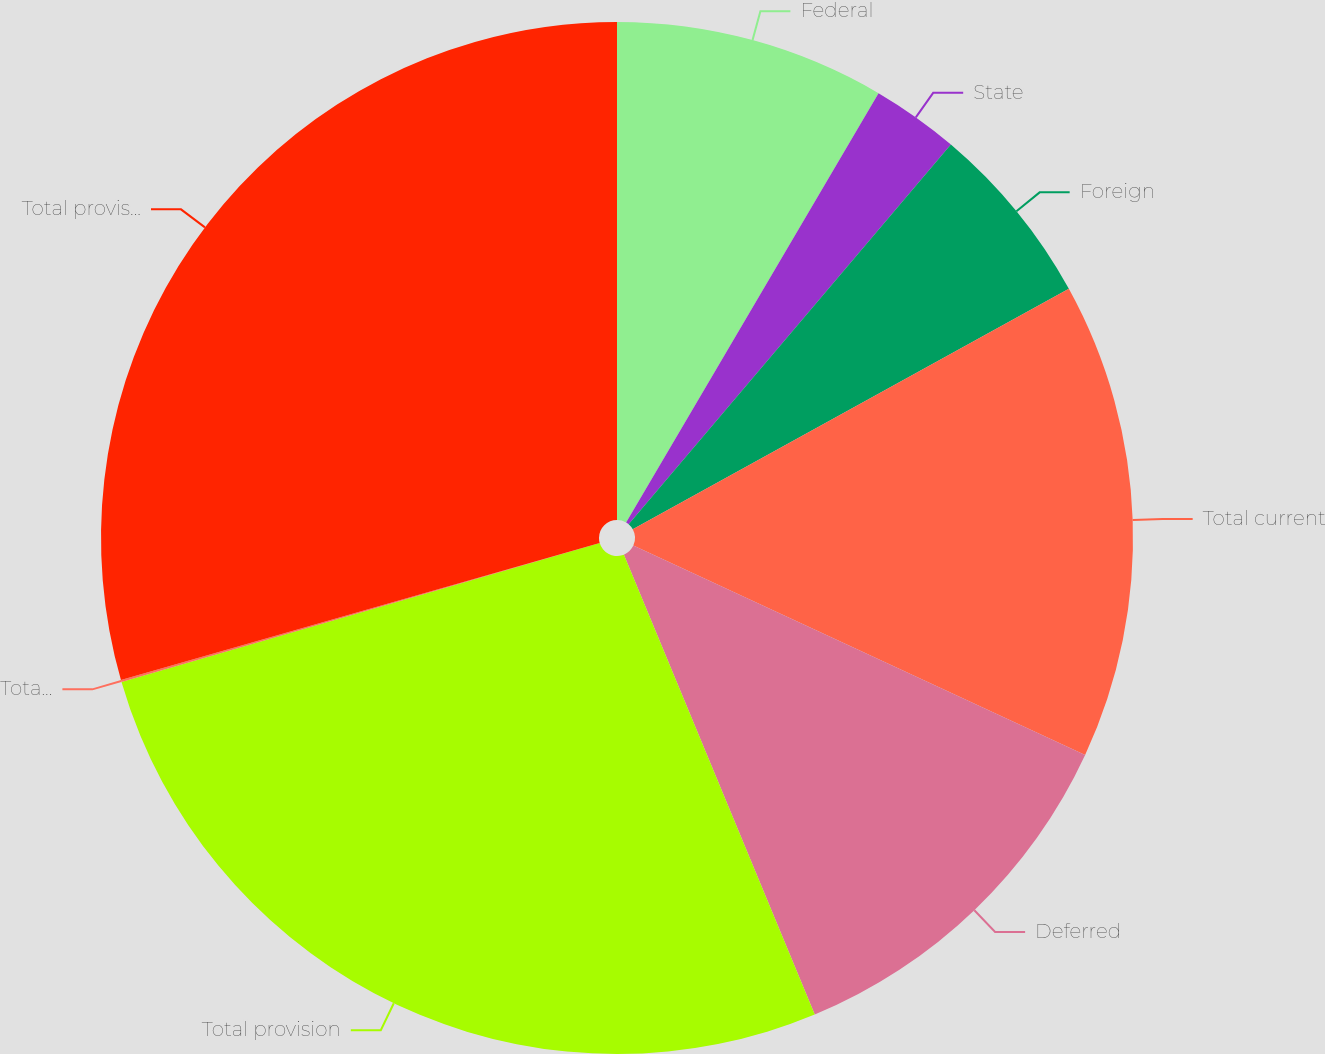<chart> <loc_0><loc_0><loc_500><loc_500><pie_chart><fcel>Federal<fcel>State<fcel>Foreign<fcel>Total current<fcel>Deferred<fcel>Total provision<fcel>Total provision (benefit) -<fcel>Total provision - continuing<nl><fcel>8.46%<fcel>2.74%<fcel>5.78%<fcel>14.93%<fcel>11.83%<fcel>26.76%<fcel>0.06%<fcel>29.44%<nl></chart> 